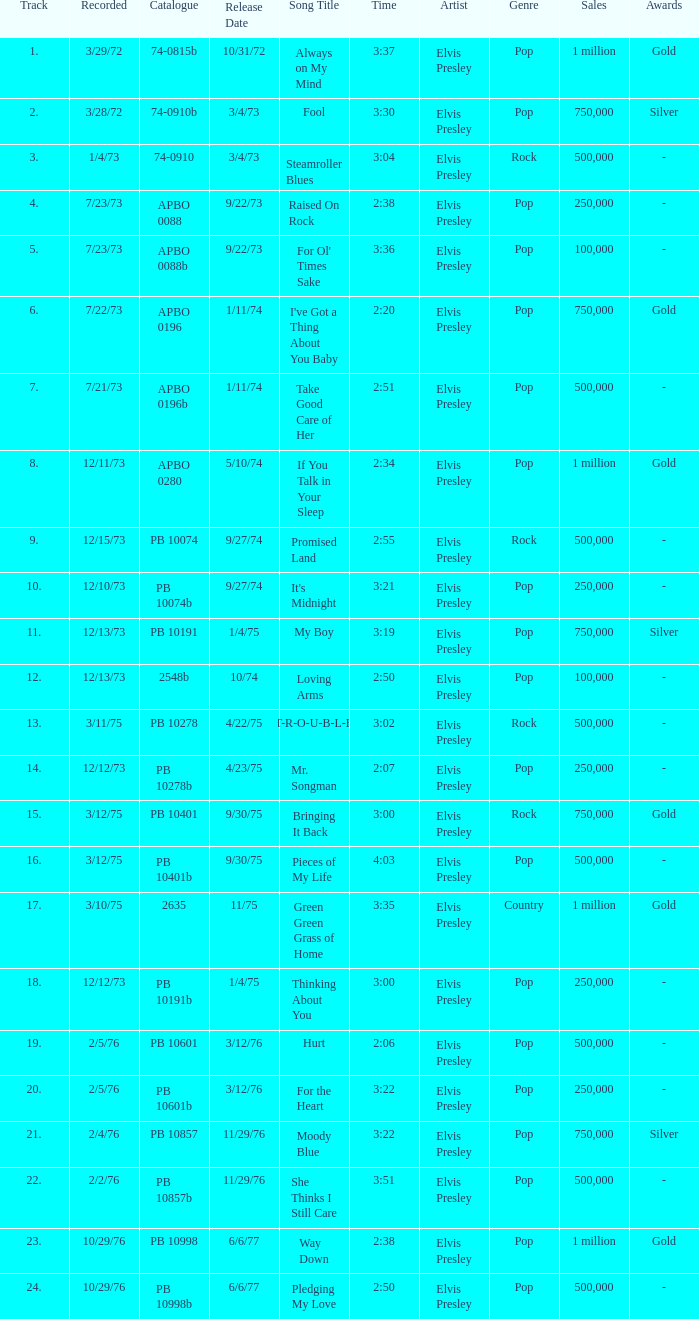Tell me the track that has the catalogue of apbo 0280 8.0. 